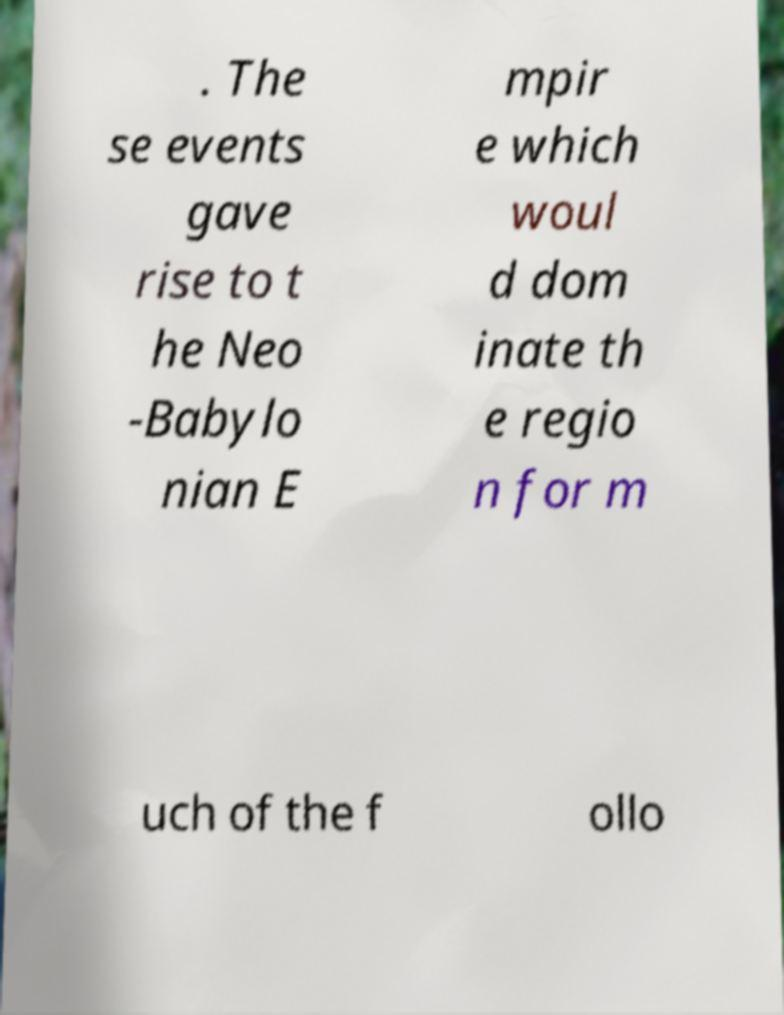Can you accurately transcribe the text from the provided image for me? . The se events gave rise to t he Neo -Babylo nian E mpir e which woul d dom inate th e regio n for m uch of the f ollo 